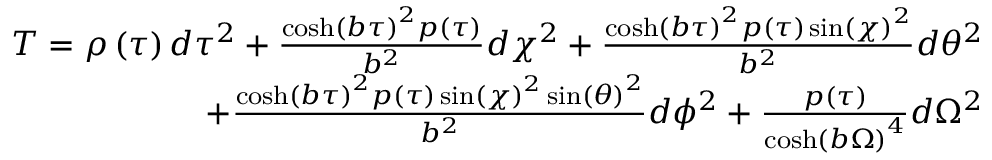<formula> <loc_0><loc_0><loc_500><loc_500>\begin{array} { r } { T = \rho \left ( { \tau } \right ) d \tau ^ { 2 } + \frac { \cosh \left ( b { \tau } \right ) ^ { 2 } p \left ( { \tau } \right ) } { b ^ { 2 } } d \chi ^ { 2 } + \frac { \cosh \left ( b { \tau } \right ) ^ { 2 } p \left ( { \tau } \right ) \sin \left ( { \chi } \right ) ^ { 2 } } { b ^ { 2 } } d \theta ^ { 2 } } \\ { + \frac { \cosh \left ( b { \tau } \right ) ^ { 2 } p \left ( { \tau } \right ) \sin \left ( { \chi } \right ) ^ { 2 } \sin \left ( { \theta } \right ) ^ { 2 } } { b ^ { 2 } } d \phi ^ { 2 } + \frac { p \left ( { \tau } \right ) } { \cosh \left ( b { \Omega } \right ) ^ { 4 } } d \Omega ^ { 2 } } \end{array}</formula> 